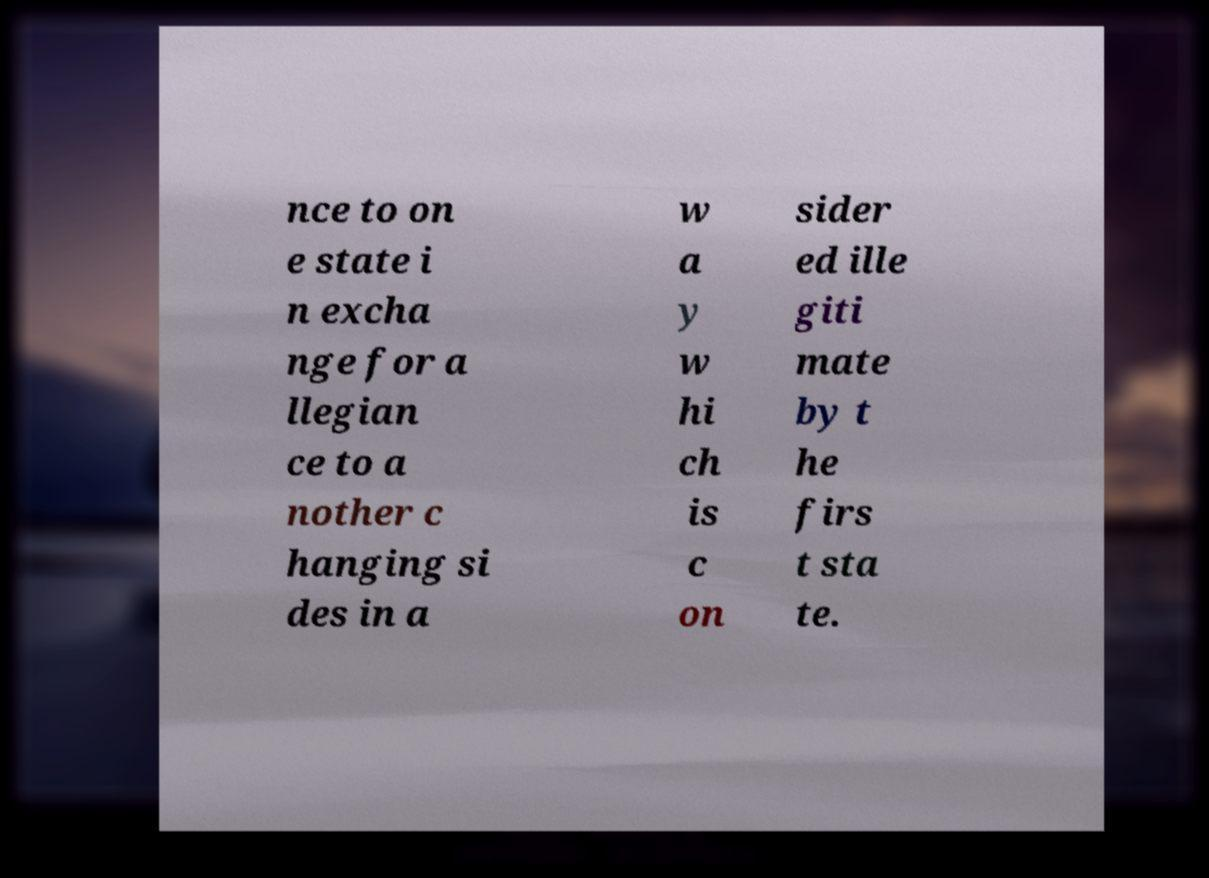Can you accurately transcribe the text from the provided image for me? nce to on e state i n excha nge for a llegian ce to a nother c hanging si des in a w a y w hi ch is c on sider ed ille giti mate by t he firs t sta te. 